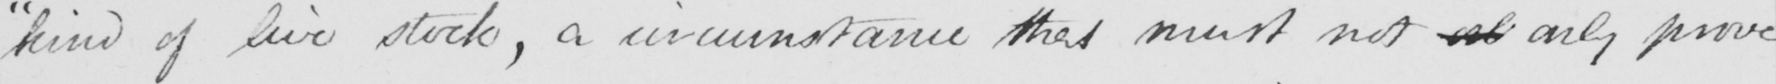What is written in this line of handwriting? "kind of live stock, a circumstance that must not <gap/> only prove 